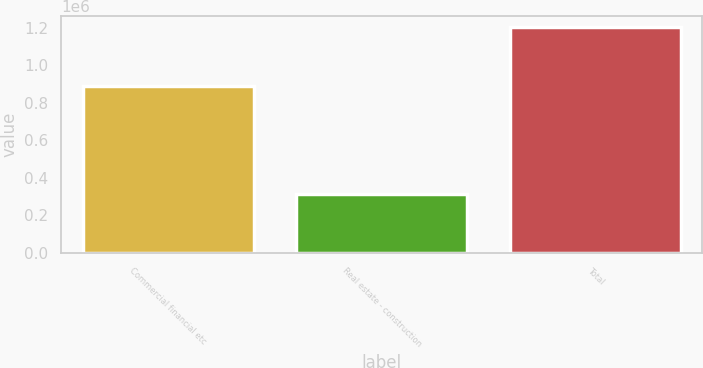<chart> <loc_0><loc_0><loc_500><loc_500><bar_chart><fcel>Commercial financial etc<fcel>Real estate - construction<fcel>Total<nl><fcel>890316<fcel>311342<fcel>1.20166e+06<nl></chart> 